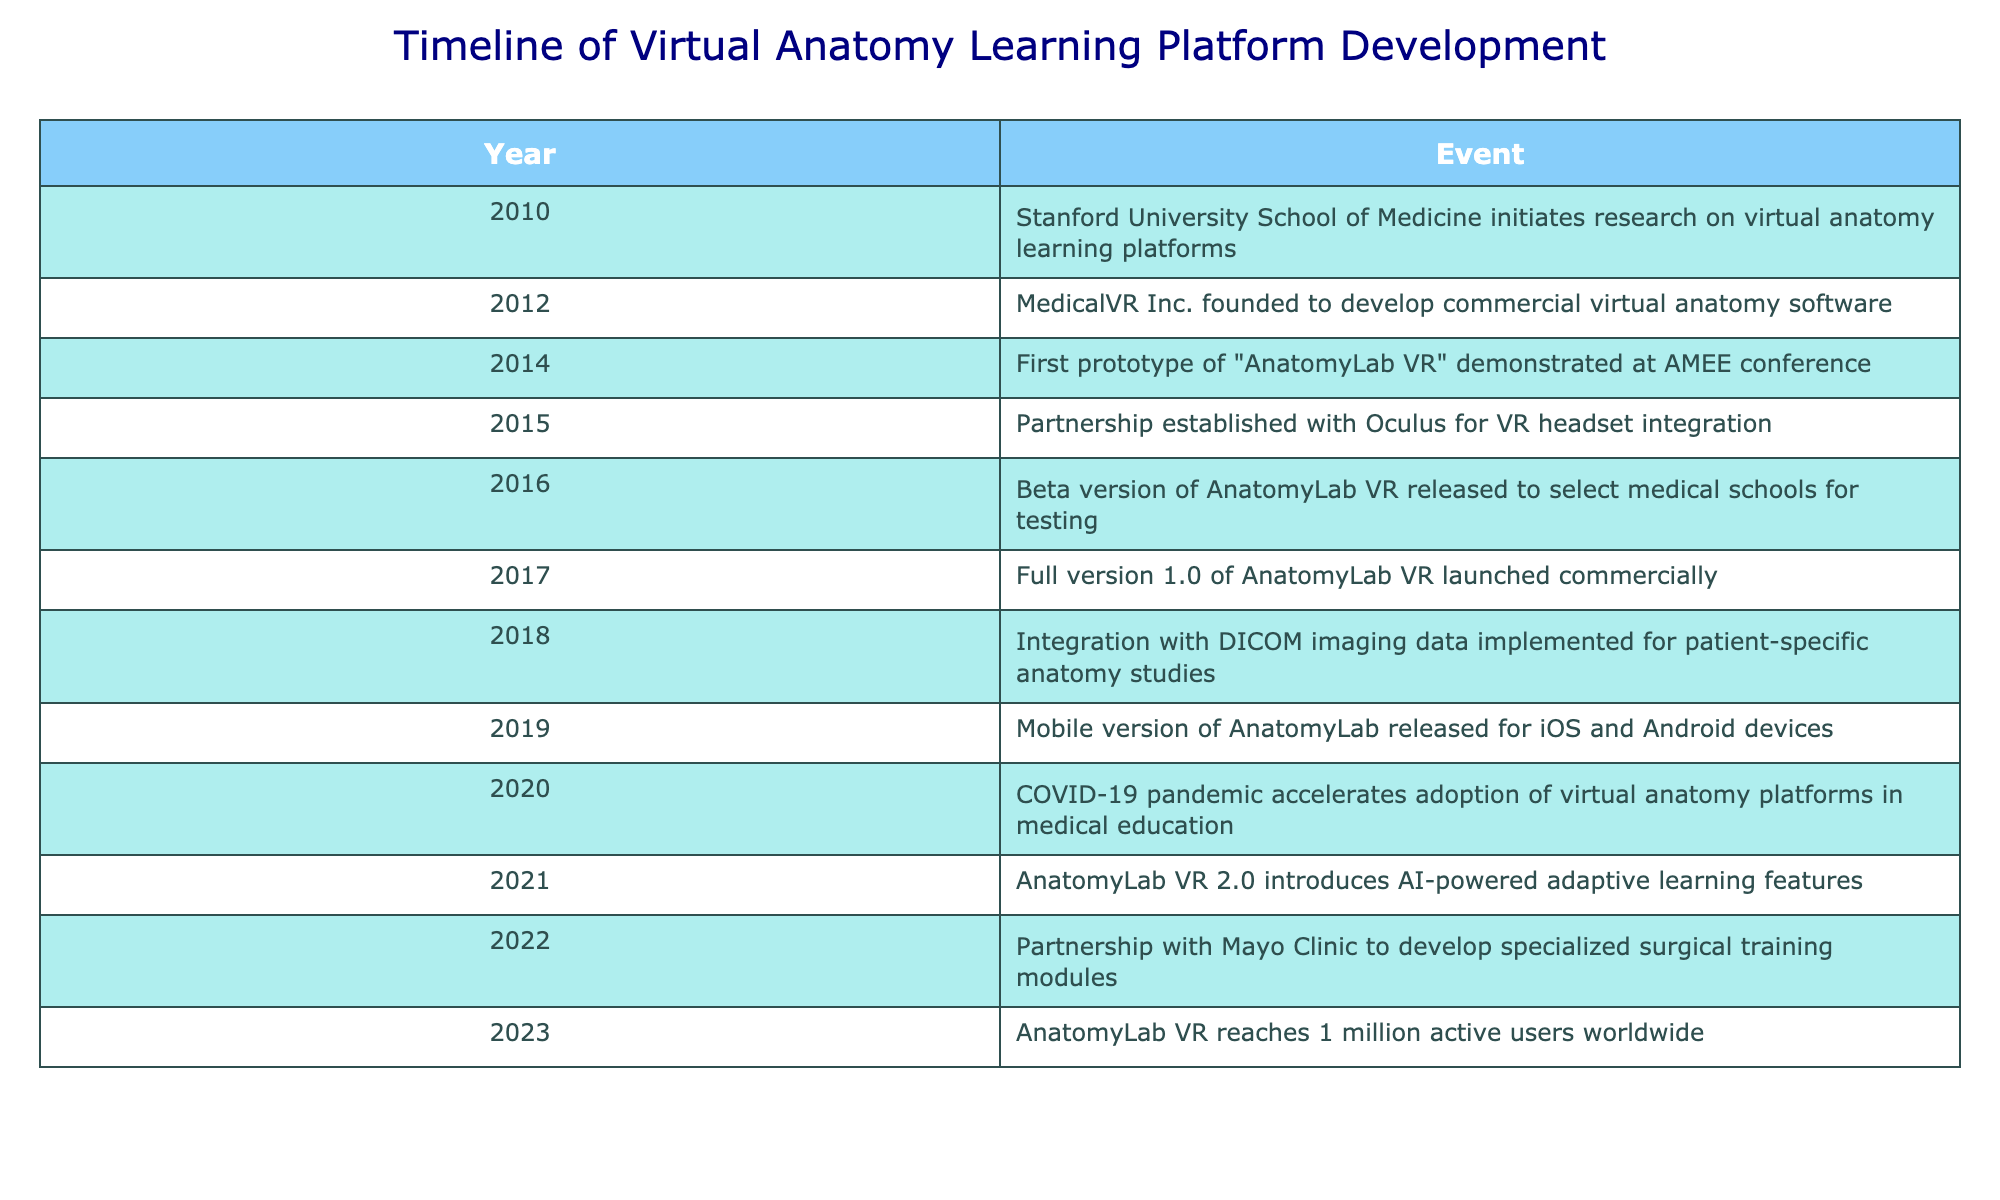What year did Stanford University initiate research on virtual anatomy learning platforms? The table shows that Stanford University School of Medicine began its research in 2010, as indicated in the first row.
Answer: 2010 In which year was the mobile version of AnatomyLab released? Looking at the timeline, the mobile version of AnatomyLab is noted in the year 2019, which is found in the second to last row of the table.
Answer: 2019 What year did the partnership with Mayo Clinic occur? The partnership with Mayo Clinic to develop surgical training modules is mentioned for the year 2022, which is clearly stated in the table.
Answer: 2022 Were AI-powered adaptive learning features introduced before or after the pandemic in 2020? According to the table, the AI-powered adaptive learning features were introduced in 2021. The COVID-19 pandemic accelerated the adoption of virtual anatomy platforms in 2020, indicating that AI features came after.
Answer: After How many years passed between the establishment of MedicalVR Inc. and the launch of the full version 1.0 of AnatomyLab VR? MedicalVR Inc. was founded in 2012, and the full version 1.0 of AnatomyLab VR was launched in 2017. By subtracting these years (2017 - 2012), we find that 5 years passed.
Answer: 5 years What is the total number of key events listed in the table? Counting the number of events outlined in the table, there are a total of 13 events from 2010 to 2023.
Answer: 13 In what year was the first prototype of AnatomyLab VR demonstrated, and how does this year relate to the launch of the beta version? The first prototype was demonstrated in 2014 and the beta version was released in 2016. We can see that two years elapsed between these two key events.
Answer: 2 years Does the first version of AnatomyLab VR predate the implementation of DICOM imaging data? Yes, according to the table, the full version 1.0 of AnatomyLab VR was launched in 2017, while the integration with DICOM imaging data is noted for 2018. Thus, the first version predates the DICOM integration.
Answer: Yes What was the significance of the COVID-19 pandemic in relation to virtual anatomy platforms? The table indicates that the COVID-19 pandemic in 2020 accelerated the adoption of virtual anatomy platforms, suggesting that the pandemic had a major impact on how swiftly these platforms were integrated into medical education.
Answer: Accelerated adoption 